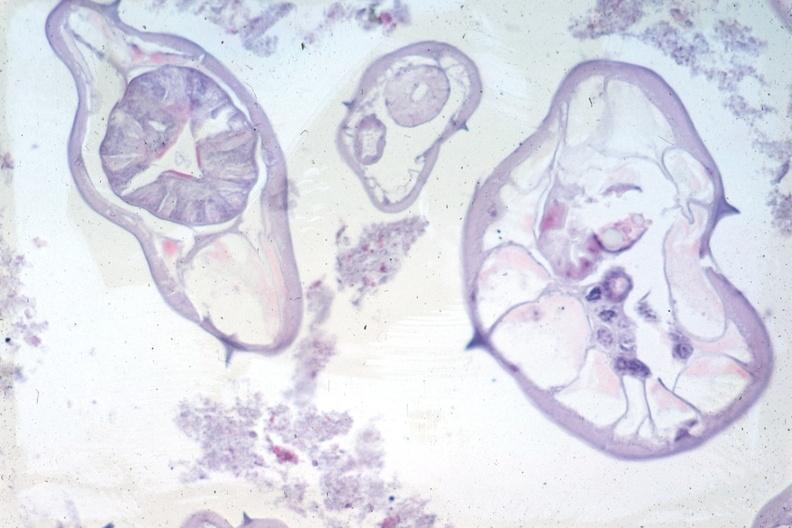s gastrointestinal present?
Answer the question using a single word or phrase. Yes 